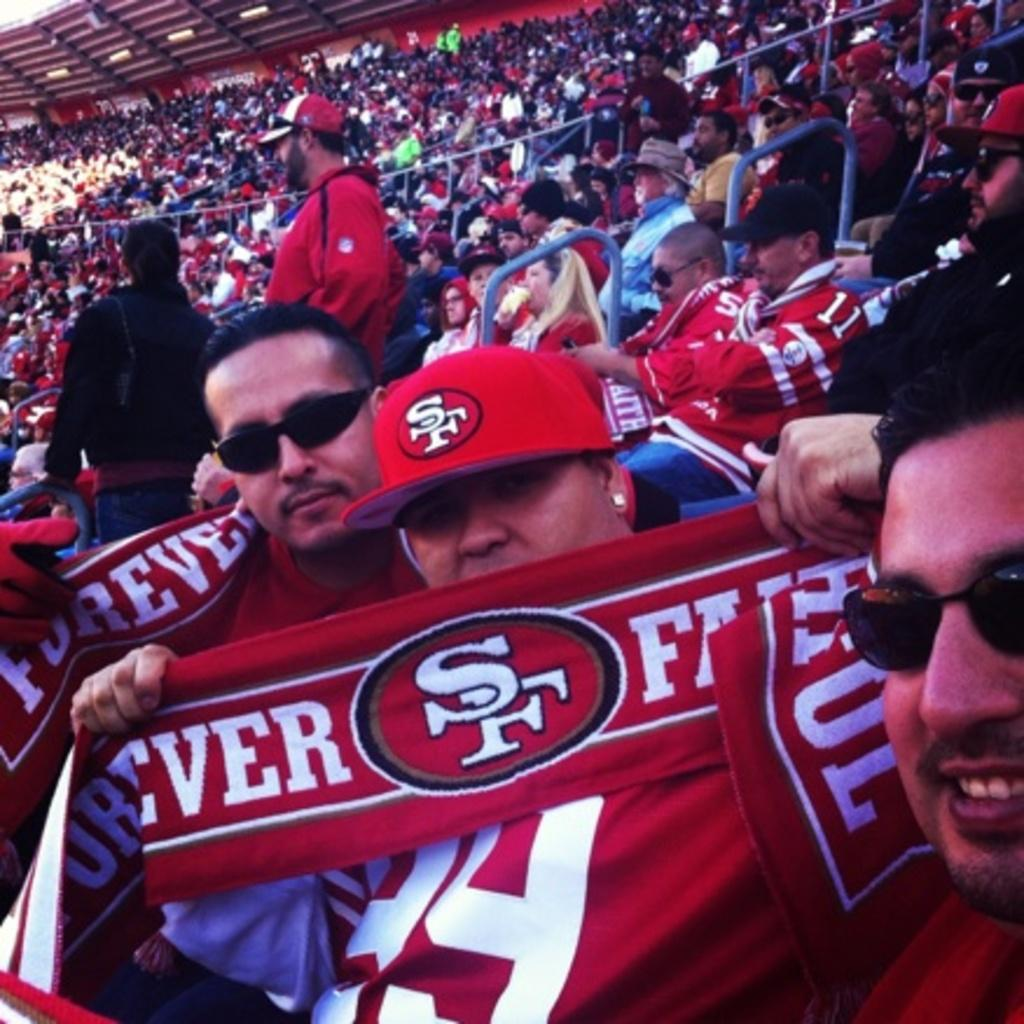<image>
Present a compact description of the photo's key features. A man holding a banner that has SF on it 